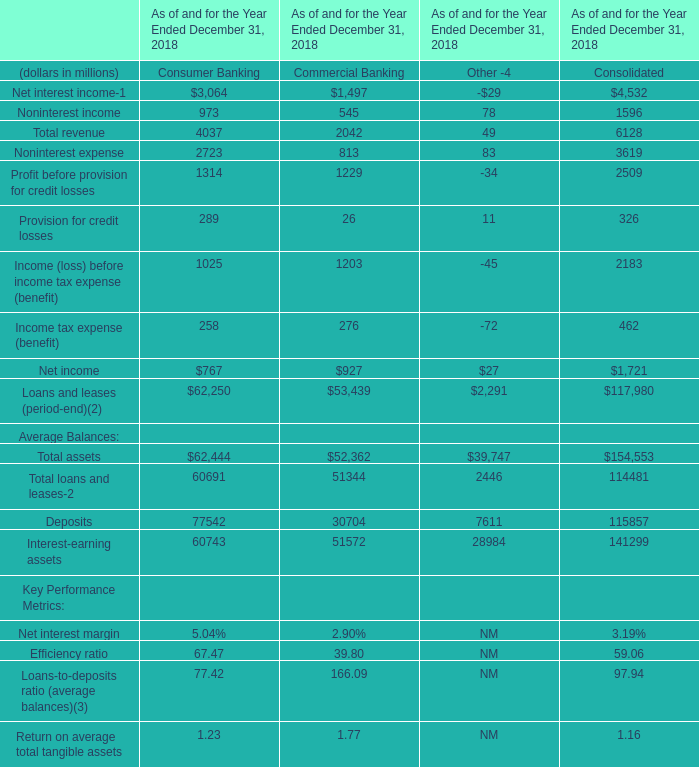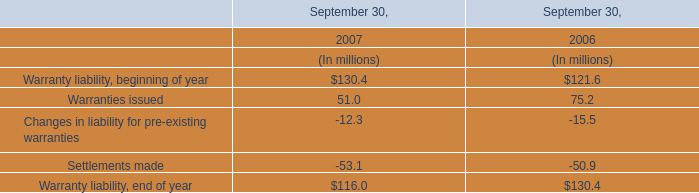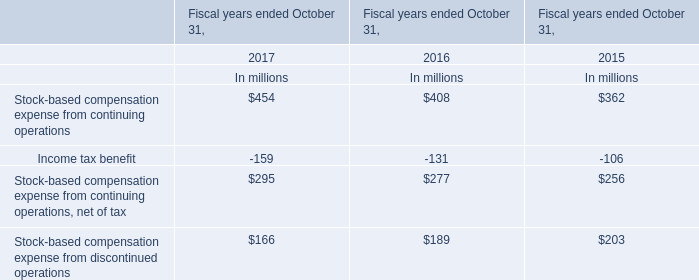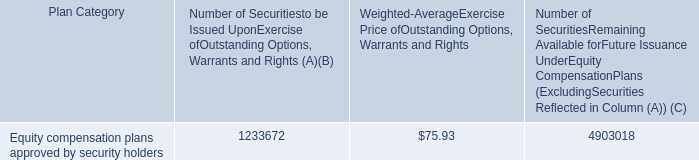Does the proportion of non-interest income in consumer banking in total larger than that of non-interest income in commercial banking in 2018? 
Computations: ((973 / 4037) - (545 / 2042))
Answer: -0.02587. 